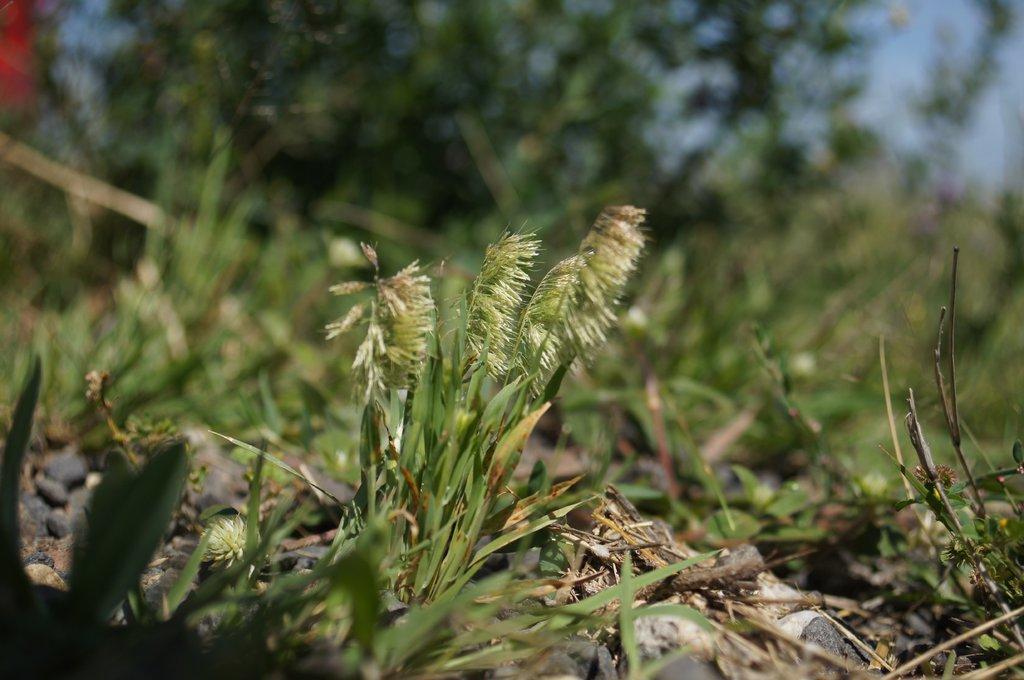Please provide a concise description of this image. In this picture we can see grass on the ground and in the background we can see trees and the sky and it is blurry. 